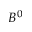Convert formula to latex. <formula><loc_0><loc_0><loc_500><loc_500>B ^ { 0 }</formula> 